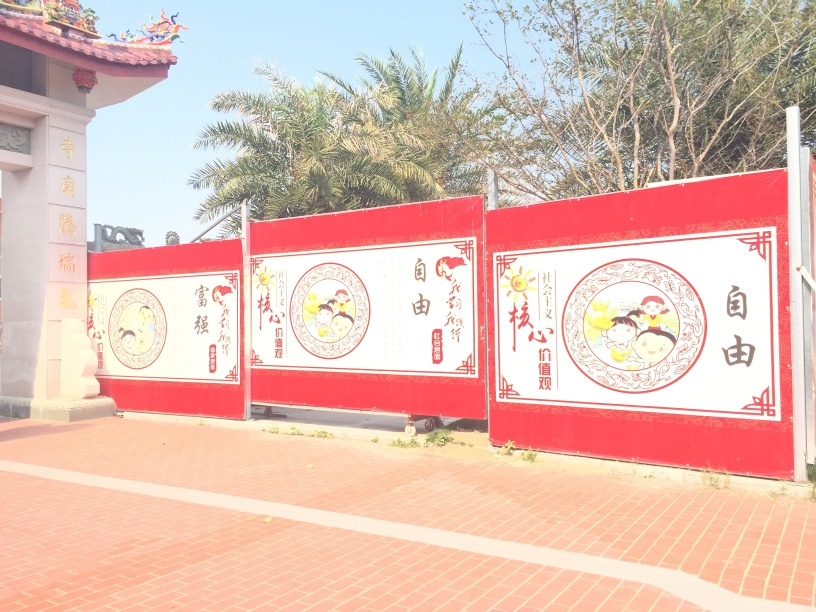What can you infer about the location of this place from the image? The architecture, such as the style of the gate and roof details in the upper left corner, along with the Chinese characters on the panels, suggest that this location might be in a Chinese-speaking area or heavily influenced by Chinese culture. The palm trees indicate a relatively warm climate. It could be a temple, cultural center, or a place where festivals are celebrated. 